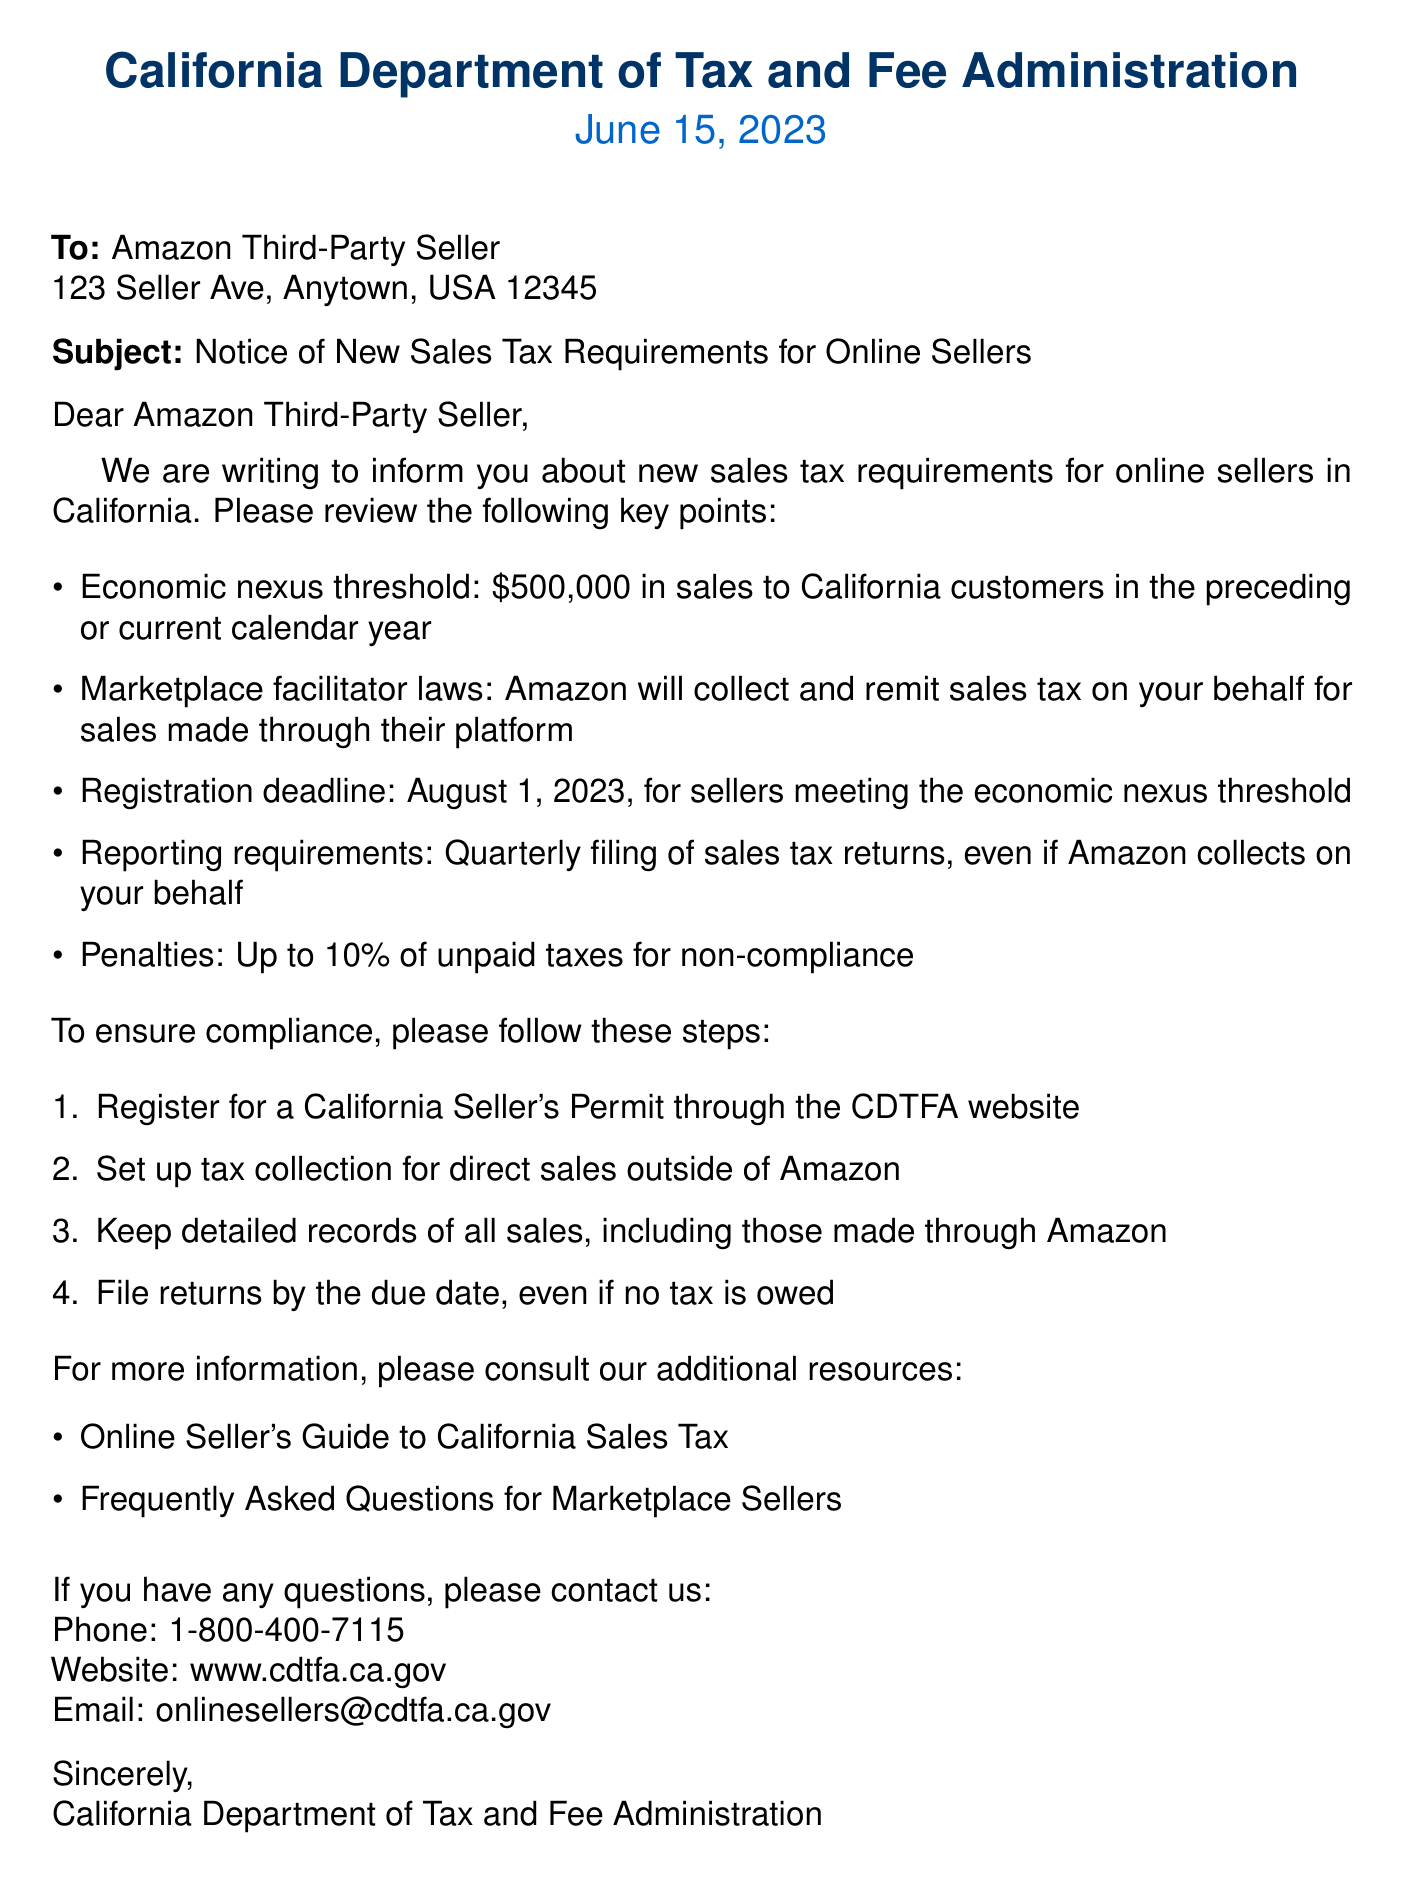What is the economic nexus threshold? The economic nexus threshold is the amount in sales to California customers that triggers tax requirements for sellers, which is stated as $500,000.
Answer: $500,000 What is the registration deadline? The registration deadline is the last date by which sellers must register to comply with the new sales tax requirements, noted in the document as August 1, 2023.
Answer: August 1, 2023 What is the penalty for non-compliance? The penalty refers to the potential financial consequence for failing to comply with the new sales tax requirements, specified in the document as up to 10 percent of unpaid taxes.
Answer: Up to 10% Who will collect and remit sales tax for Amazon sellers? This refers to the entity responsible for handling sales tax on behalf of the Amazon sellers as mentioned in the document, which is Amazon.
Answer: Amazon What should sellers do for direct sales outside of Amazon? This question addresses the actions sellers must take regarding sales made independently of Amazon as outlined in the document, which is to set up tax collection.
Answer: Set up tax collection How often must a seller file sales tax returns? The frequency of filing tax returns as required by the new sales tax requirements is mentioned in the document, which states quarterly.
Answer: Quarterly 